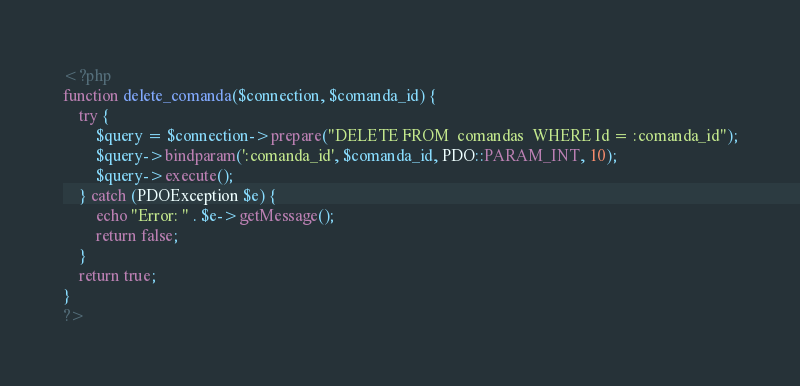<code> <loc_0><loc_0><loc_500><loc_500><_PHP_><?php
function delete_comanda($connection, $comanda_id) {
    try {
        $query = $connection->prepare("DELETE FROM  comandas  WHERE Id = :comanda_id");
        $query->bindparam(':comanda_id', $comanda_id, PDO::PARAM_INT, 10);
        $query->execute();
    } catch (PDOException $e) {
        echo "Error: " . $e->getMessage();
        return false;
    }
    return true;
}
?></code> 